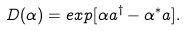Convert formula to latex. <formula><loc_0><loc_0><loc_500><loc_500>D ( \alpha ) = e x p [ \alpha a ^ { \dag } - \alpha ^ { * } a ] .</formula> 